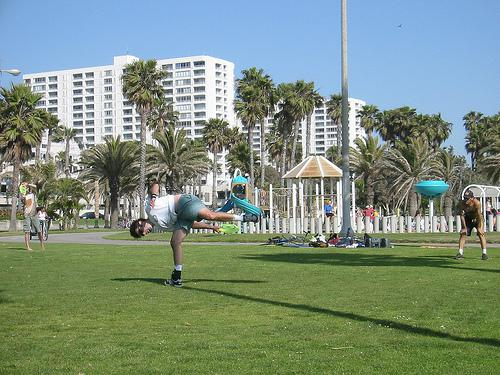Question: what is he doing?
Choices:
A. Sitting.
B. Falling.
C. Sleeping.
D. Rolling.
Answer with the letter. Answer: B Question: what is green?
Choices:
A. Money.
B. Herbs.
C. Paint.
D. The grass.
Answer with the letter. Answer: D Question: who is falling?
Choices:
A. The guy.
B. Dog.
C. Cat.
D. Bird.
Answer with the letter. Answer: A Question: where is he?
Choices:
A. Park.
B. Field.
C. Kitchen.
D. Restroom.
Answer with the letter. Answer: A Question: what is blue?
Choices:
A. The sky.
B. The ball.
C. The paint.
D. The fence.
Answer with the letter. Answer: A 